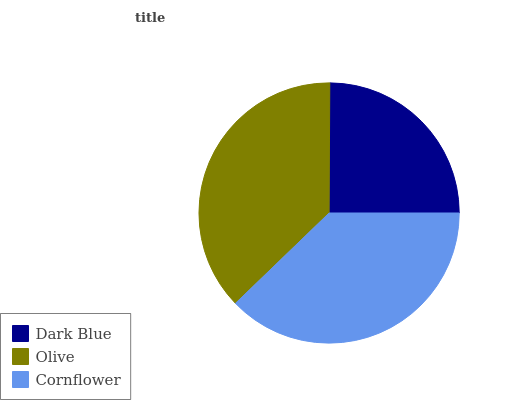Is Dark Blue the minimum?
Answer yes or no. Yes. Is Cornflower the maximum?
Answer yes or no. Yes. Is Olive the minimum?
Answer yes or no. No. Is Olive the maximum?
Answer yes or no. No. Is Olive greater than Dark Blue?
Answer yes or no. Yes. Is Dark Blue less than Olive?
Answer yes or no. Yes. Is Dark Blue greater than Olive?
Answer yes or no. No. Is Olive less than Dark Blue?
Answer yes or no. No. Is Olive the high median?
Answer yes or no. Yes. Is Olive the low median?
Answer yes or no. Yes. Is Dark Blue the high median?
Answer yes or no. No. Is Cornflower the low median?
Answer yes or no. No. 